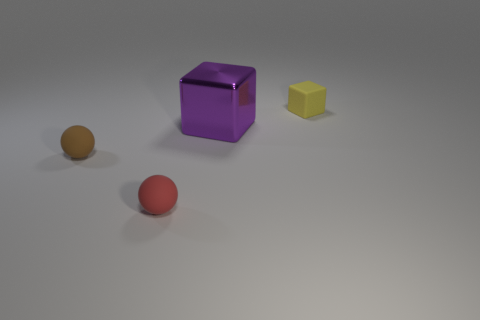There is another thing that is the same shape as the small brown object; what is its color?
Ensure brevity in your answer.  Red. Do the ball that is to the left of the red rubber thing and the large block have the same material?
Make the answer very short. No. Is the size of the purple object the same as the red rubber ball?
Provide a short and direct response. No. What number of objects are either purple cubes or yellow matte blocks behind the small brown matte thing?
Make the answer very short. 2. What is the material of the small red thing?
Give a very brief answer. Rubber. Does the purple object have the same shape as the tiny yellow thing?
Ensure brevity in your answer.  Yes. What is the size of the block that is on the left side of the small yellow thing that is on the right side of the red ball that is to the left of the big purple block?
Ensure brevity in your answer.  Large. How many other things are made of the same material as the big cube?
Offer a terse response. 0. There is a small matte object that is behind the large purple metal cube; what is its color?
Your response must be concise. Yellow. There is a tiny thing that is in front of the rubber ball on the left side of the object that is in front of the brown matte sphere; what is its material?
Make the answer very short. Rubber. 